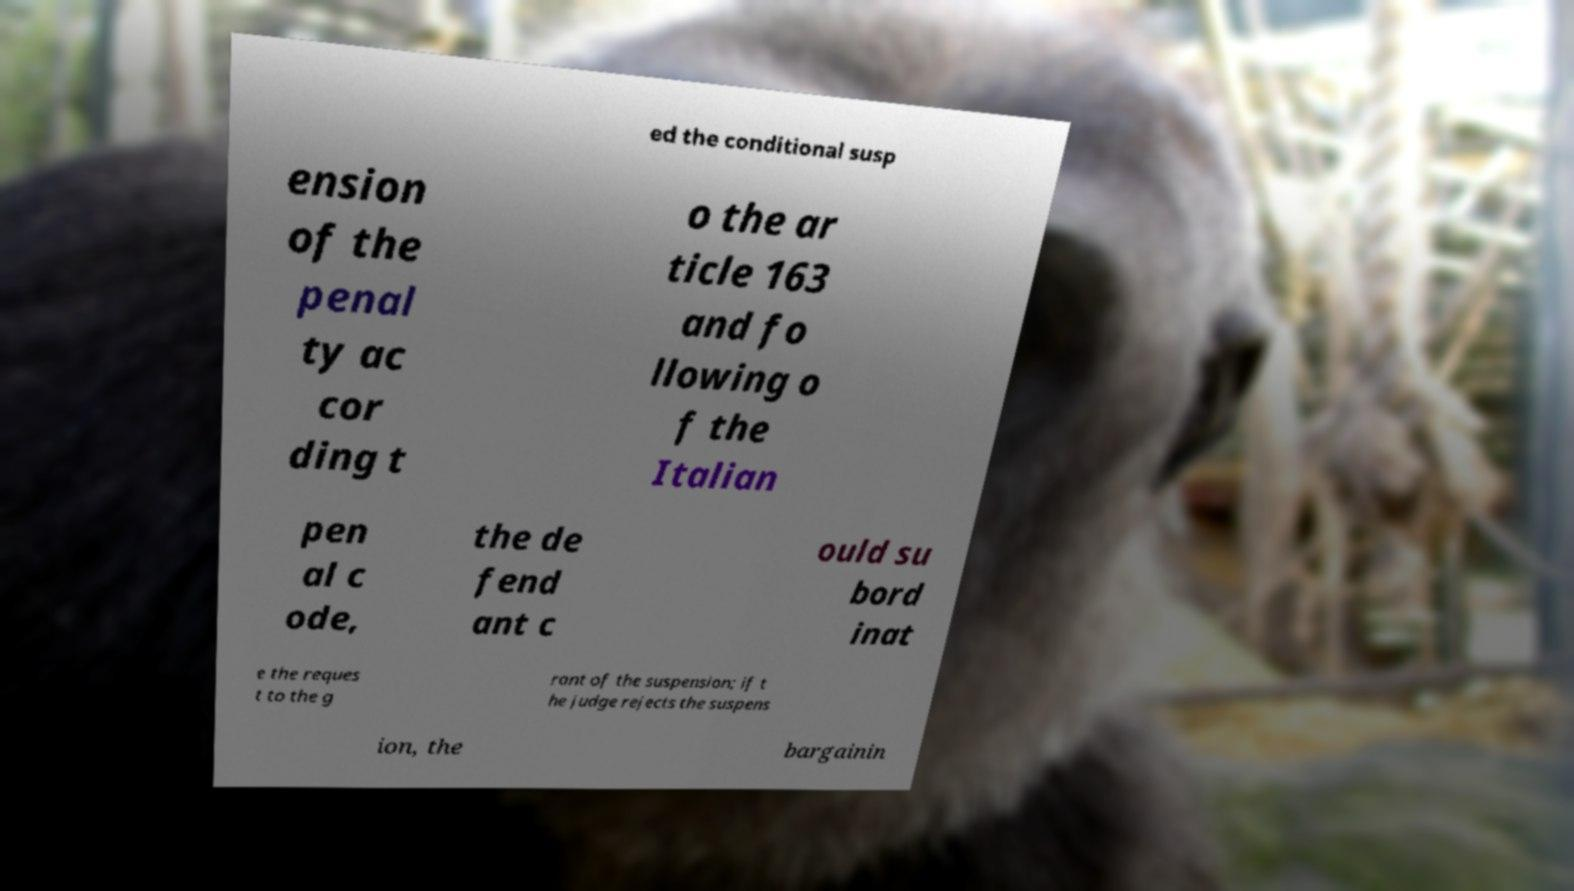Could you assist in decoding the text presented in this image and type it out clearly? ed the conditional susp ension of the penal ty ac cor ding t o the ar ticle 163 and fo llowing o f the Italian pen al c ode, the de fend ant c ould su bord inat e the reques t to the g rant of the suspension; if t he judge rejects the suspens ion, the bargainin 